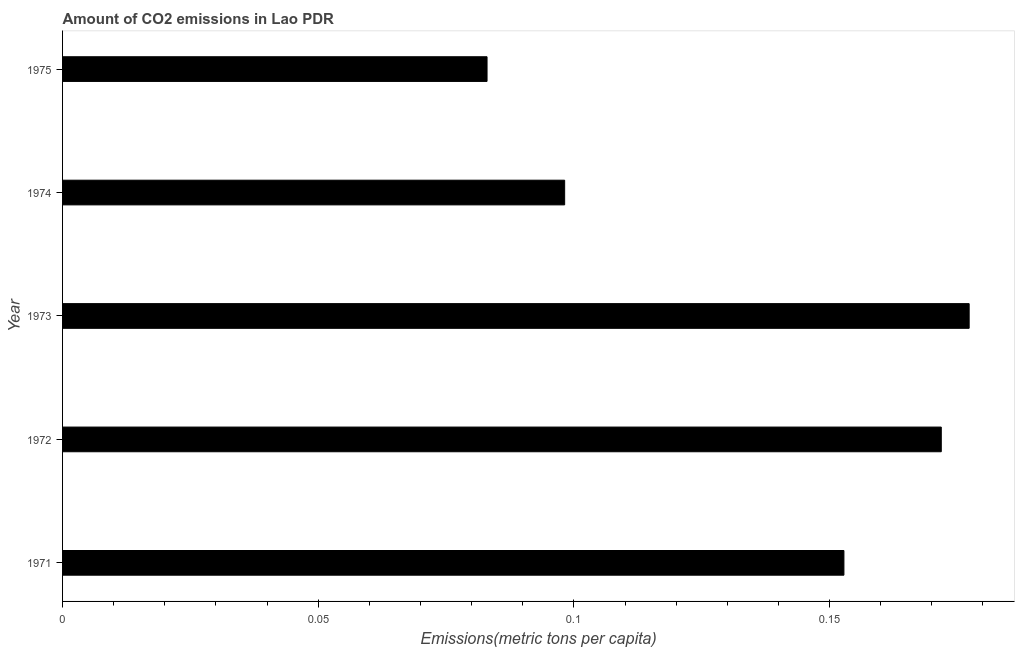Does the graph contain any zero values?
Keep it short and to the point. No. Does the graph contain grids?
Offer a very short reply. No. What is the title of the graph?
Offer a very short reply. Amount of CO2 emissions in Lao PDR. What is the label or title of the X-axis?
Your answer should be very brief. Emissions(metric tons per capita). What is the label or title of the Y-axis?
Make the answer very short. Year. What is the amount of co2 emissions in 1971?
Your answer should be very brief. 0.15. Across all years, what is the maximum amount of co2 emissions?
Your response must be concise. 0.18. Across all years, what is the minimum amount of co2 emissions?
Provide a short and direct response. 0.08. In which year was the amount of co2 emissions minimum?
Your answer should be very brief. 1975. What is the sum of the amount of co2 emissions?
Provide a succinct answer. 0.68. What is the difference between the amount of co2 emissions in 1972 and 1974?
Your answer should be very brief. 0.07. What is the average amount of co2 emissions per year?
Offer a terse response. 0.14. What is the median amount of co2 emissions?
Your answer should be very brief. 0.15. Do a majority of the years between 1975 and 1974 (inclusive) have amount of co2 emissions greater than 0.16 metric tons per capita?
Keep it short and to the point. No. Is the amount of co2 emissions in 1971 less than that in 1972?
Your answer should be compact. Yes. What is the difference between the highest and the second highest amount of co2 emissions?
Ensure brevity in your answer.  0.01. What is the difference between the highest and the lowest amount of co2 emissions?
Provide a short and direct response. 0.09. In how many years, is the amount of co2 emissions greater than the average amount of co2 emissions taken over all years?
Offer a terse response. 3. How many bars are there?
Offer a terse response. 5. Are all the bars in the graph horizontal?
Give a very brief answer. Yes. How many years are there in the graph?
Your answer should be compact. 5. What is the Emissions(metric tons per capita) of 1971?
Your answer should be compact. 0.15. What is the Emissions(metric tons per capita) in 1972?
Offer a terse response. 0.17. What is the Emissions(metric tons per capita) of 1973?
Your answer should be compact. 0.18. What is the Emissions(metric tons per capita) in 1974?
Your answer should be compact. 0.1. What is the Emissions(metric tons per capita) of 1975?
Your response must be concise. 0.08. What is the difference between the Emissions(metric tons per capita) in 1971 and 1972?
Your answer should be compact. -0.02. What is the difference between the Emissions(metric tons per capita) in 1971 and 1973?
Keep it short and to the point. -0.02. What is the difference between the Emissions(metric tons per capita) in 1971 and 1974?
Make the answer very short. 0.05. What is the difference between the Emissions(metric tons per capita) in 1971 and 1975?
Your answer should be compact. 0.07. What is the difference between the Emissions(metric tons per capita) in 1972 and 1973?
Keep it short and to the point. -0.01. What is the difference between the Emissions(metric tons per capita) in 1972 and 1974?
Your answer should be compact. 0.07. What is the difference between the Emissions(metric tons per capita) in 1972 and 1975?
Offer a very short reply. 0.09. What is the difference between the Emissions(metric tons per capita) in 1973 and 1974?
Offer a very short reply. 0.08. What is the difference between the Emissions(metric tons per capita) in 1973 and 1975?
Offer a terse response. 0.09. What is the difference between the Emissions(metric tons per capita) in 1974 and 1975?
Offer a very short reply. 0.02. What is the ratio of the Emissions(metric tons per capita) in 1971 to that in 1972?
Offer a terse response. 0.89. What is the ratio of the Emissions(metric tons per capita) in 1971 to that in 1973?
Provide a succinct answer. 0.86. What is the ratio of the Emissions(metric tons per capita) in 1971 to that in 1974?
Provide a short and direct response. 1.56. What is the ratio of the Emissions(metric tons per capita) in 1971 to that in 1975?
Your answer should be very brief. 1.84. What is the ratio of the Emissions(metric tons per capita) in 1972 to that in 1975?
Offer a very short reply. 2.07. What is the ratio of the Emissions(metric tons per capita) in 1973 to that in 1974?
Offer a very short reply. 1.81. What is the ratio of the Emissions(metric tons per capita) in 1973 to that in 1975?
Offer a very short reply. 2.14. What is the ratio of the Emissions(metric tons per capita) in 1974 to that in 1975?
Keep it short and to the point. 1.18. 